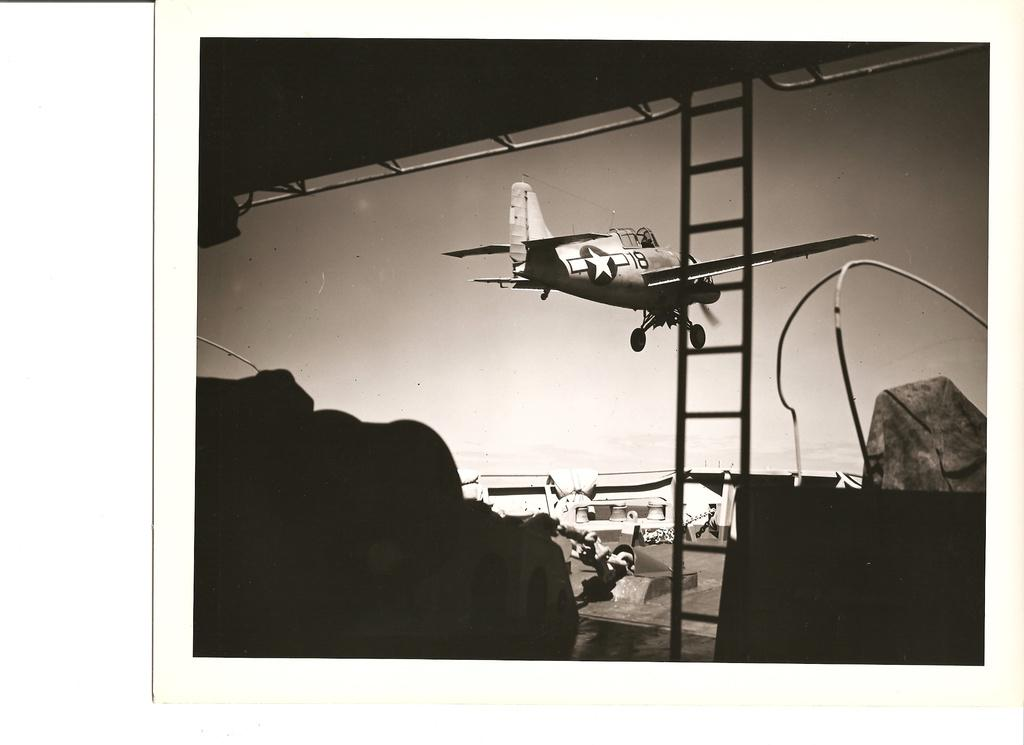What is the color scheme of the image? The image is black and white. What can be seen in the sky in the image? There is an aircraft flying in the image. What object is present on the ground in the image? There is a ladder in the image. What type of structure is visible in the background of the image? There is a building in the background of the image. What type of advice can be seen written on the aircraft in the image? There is no advice written on the aircraft in the image, as it is a black and white photograph with no visible text. 